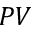Convert formula to latex. <formula><loc_0><loc_0><loc_500><loc_500>P V</formula> 